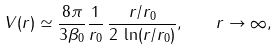Convert formula to latex. <formula><loc_0><loc_0><loc_500><loc_500>V ( r ) \simeq \frac { 8 \pi } { 3 \beta _ { 0 } } \frac { 1 } { r _ { 0 } } \, \frac { r / r _ { 0 } } { 2 \, \ln ( r / r _ { 0 } ) } , \quad r \to \infty ,</formula> 